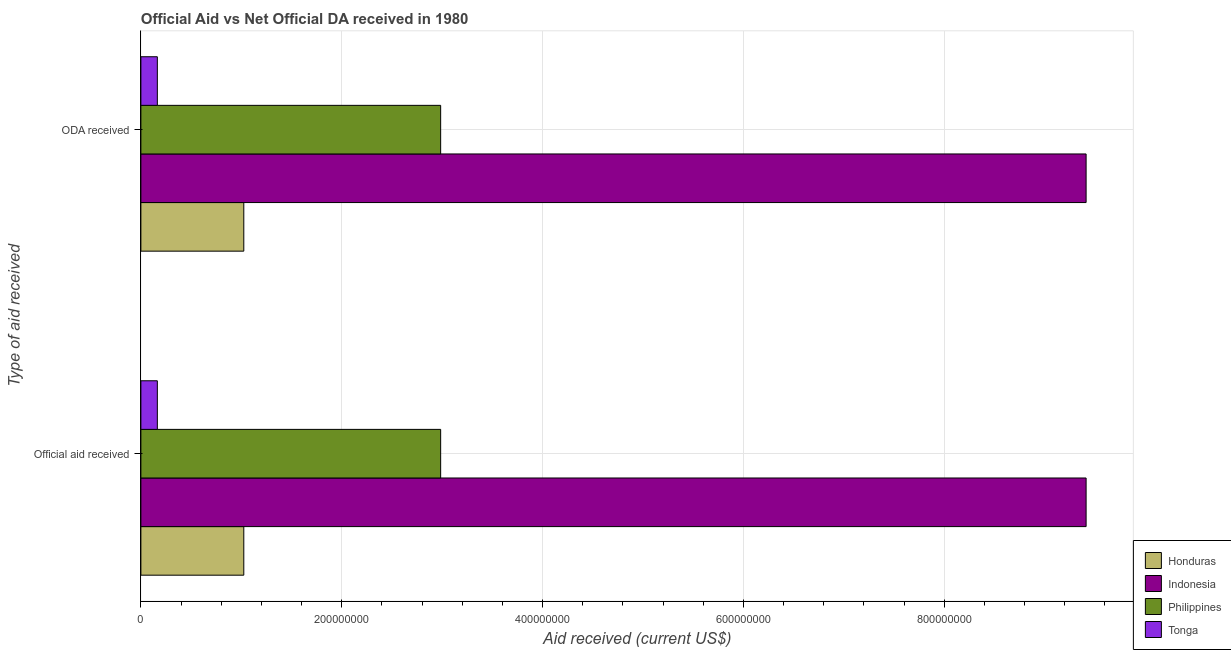How many groups of bars are there?
Keep it short and to the point. 2. How many bars are there on the 2nd tick from the top?
Keep it short and to the point. 4. How many bars are there on the 1st tick from the bottom?
Ensure brevity in your answer.  4. What is the label of the 2nd group of bars from the top?
Provide a succinct answer. Official aid received. What is the oda received in Tonga?
Offer a very short reply. 1.64e+07. Across all countries, what is the maximum official aid received?
Make the answer very short. 9.41e+08. Across all countries, what is the minimum oda received?
Your answer should be compact. 1.64e+07. In which country was the oda received maximum?
Provide a succinct answer. Indonesia. In which country was the oda received minimum?
Your answer should be compact. Tonga. What is the total official aid received in the graph?
Provide a short and direct response. 1.36e+09. What is the difference between the official aid received in Indonesia and that in Tonga?
Your answer should be compact. 9.25e+08. What is the difference between the official aid received in Philippines and the oda received in Honduras?
Your answer should be compact. 1.96e+08. What is the average oda received per country?
Give a very brief answer. 3.40e+08. What is the difference between the oda received and official aid received in Philippines?
Make the answer very short. 0. In how many countries, is the oda received greater than 200000000 US$?
Keep it short and to the point. 2. What is the ratio of the official aid received in Philippines to that in Indonesia?
Give a very brief answer. 0.32. What does the 4th bar from the top in ODA received represents?
Your answer should be very brief. Honduras. How many countries are there in the graph?
Give a very brief answer. 4. Does the graph contain any zero values?
Provide a succinct answer. No. How many legend labels are there?
Give a very brief answer. 4. How are the legend labels stacked?
Keep it short and to the point. Vertical. What is the title of the graph?
Give a very brief answer. Official Aid vs Net Official DA received in 1980 . Does "Malaysia" appear as one of the legend labels in the graph?
Your answer should be very brief. No. What is the label or title of the X-axis?
Ensure brevity in your answer.  Aid received (current US$). What is the label or title of the Y-axis?
Your answer should be compact. Type of aid received. What is the Aid received (current US$) in Honduras in Official aid received?
Offer a terse response. 1.02e+08. What is the Aid received (current US$) in Indonesia in Official aid received?
Give a very brief answer. 9.41e+08. What is the Aid received (current US$) of Philippines in Official aid received?
Make the answer very short. 2.99e+08. What is the Aid received (current US$) in Tonga in Official aid received?
Offer a very short reply. 1.64e+07. What is the Aid received (current US$) of Honduras in ODA received?
Offer a terse response. 1.02e+08. What is the Aid received (current US$) of Indonesia in ODA received?
Make the answer very short. 9.41e+08. What is the Aid received (current US$) of Philippines in ODA received?
Your response must be concise. 2.99e+08. What is the Aid received (current US$) of Tonga in ODA received?
Offer a terse response. 1.64e+07. Across all Type of aid received, what is the maximum Aid received (current US$) in Honduras?
Make the answer very short. 1.02e+08. Across all Type of aid received, what is the maximum Aid received (current US$) of Indonesia?
Make the answer very short. 9.41e+08. Across all Type of aid received, what is the maximum Aid received (current US$) of Philippines?
Make the answer very short. 2.99e+08. Across all Type of aid received, what is the maximum Aid received (current US$) in Tonga?
Make the answer very short. 1.64e+07. Across all Type of aid received, what is the minimum Aid received (current US$) in Honduras?
Ensure brevity in your answer.  1.02e+08. Across all Type of aid received, what is the minimum Aid received (current US$) of Indonesia?
Offer a very short reply. 9.41e+08. Across all Type of aid received, what is the minimum Aid received (current US$) in Philippines?
Offer a very short reply. 2.99e+08. Across all Type of aid received, what is the minimum Aid received (current US$) in Tonga?
Provide a short and direct response. 1.64e+07. What is the total Aid received (current US$) in Honduras in the graph?
Ensure brevity in your answer.  2.05e+08. What is the total Aid received (current US$) in Indonesia in the graph?
Make the answer very short. 1.88e+09. What is the total Aid received (current US$) of Philippines in the graph?
Your answer should be compact. 5.97e+08. What is the total Aid received (current US$) of Tonga in the graph?
Provide a succinct answer. 3.28e+07. What is the difference between the Aid received (current US$) in Philippines in Official aid received and that in ODA received?
Make the answer very short. 0. What is the difference between the Aid received (current US$) in Tonga in Official aid received and that in ODA received?
Provide a short and direct response. 0. What is the difference between the Aid received (current US$) of Honduras in Official aid received and the Aid received (current US$) of Indonesia in ODA received?
Your response must be concise. -8.39e+08. What is the difference between the Aid received (current US$) of Honduras in Official aid received and the Aid received (current US$) of Philippines in ODA received?
Keep it short and to the point. -1.96e+08. What is the difference between the Aid received (current US$) of Honduras in Official aid received and the Aid received (current US$) of Tonga in ODA received?
Provide a short and direct response. 8.61e+07. What is the difference between the Aid received (current US$) in Indonesia in Official aid received and the Aid received (current US$) in Philippines in ODA received?
Your answer should be very brief. 6.43e+08. What is the difference between the Aid received (current US$) in Indonesia in Official aid received and the Aid received (current US$) in Tonga in ODA received?
Your response must be concise. 9.25e+08. What is the difference between the Aid received (current US$) in Philippines in Official aid received and the Aid received (current US$) in Tonga in ODA received?
Provide a short and direct response. 2.82e+08. What is the average Aid received (current US$) of Honduras per Type of aid received?
Offer a terse response. 1.02e+08. What is the average Aid received (current US$) of Indonesia per Type of aid received?
Make the answer very short. 9.41e+08. What is the average Aid received (current US$) of Philippines per Type of aid received?
Your response must be concise. 2.99e+08. What is the average Aid received (current US$) of Tonga per Type of aid received?
Give a very brief answer. 1.64e+07. What is the difference between the Aid received (current US$) of Honduras and Aid received (current US$) of Indonesia in Official aid received?
Make the answer very short. -8.39e+08. What is the difference between the Aid received (current US$) of Honduras and Aid received (current US$) of Philippines in Official aid received?
Give a very brief answer. -1.96e+08. What is the difference between the Aid received (current US$) in Honduras and Aid received (current US$) in Tonga in Official aid received?
Your answer should be very brief. 8.61e+07. What is the difference between the Aid received (current US$) of Indonesia and Aid received (current US$) of Philippines in Official aid received?
Keep it short and to the point. 6.43e+08. What is the difference between the Aid received (current US$) of Indonesia and Aid received (current US$) of Tonga in Official aid received?
Your answer should be very brief. 9.25e+08. What is the difference between the Aid received (current US$) in Philippines and Aid received (current US$) in Tonga in Official aid received?
Provide a short and direct response. 2.82e+08. What is the difference between the Aid received (current US$) of Honduras and Aid received (current US$) of Indonesia in ODA received?
Your answer should be very brief. -8.39e+08. What is the difference between the Aid received (current US$) in Honduras and Aid received (current US$) in Philippines in ODA received?
Provide a short and direct response. -1.96e+08. What is the difference between the Aid received (current US$) of Honduras and Aid received (current US$) of Tonga in ODA received?
Your response must be concise. 8.61e+07. What is the difference between the Aid received (current US$) in Indonesia and Aid received (current US$) in Philippines in ODA received?
Offer a terse response. 6.43e+08. What is the difference between the Aid received (current US$) of Indonesia and Aid received (current US$) of Tonga in ODA received?
Give a very brief answer. 9.25e+08. What is the difference between the Aid received (current US$) of Philippines and Aid received (current US$) of Tonga in ODA received?
Give a very brief answer. 2.82e+08. What is the ratio of the Aid received (current US$) in Honduras in Official aid received to that in ODA received?
Provide a succinct answer. 1. What is the ratio of the Aid received (current US$) in Indonesia in Official aid received to that in ODA received?
Your answer should be compact. 1. What is the difference between the highest and the second highest Aid received (current US$) in Honduras?
Give a very brief answer. 0. What is the difference between the highest and the second highest Aid received (current US$) in Indonesia?
Keep it short and to the point. 0. What is the difference between the highest and the second highest Aid received (current US$) in Philippines?
Ensure brevity in your answer.  0. What is the difference between the highest and the lowest Aid received (current US$) of Indonesia?
Keep it short and to the point. 0. What is the difference between the highest and the lowest Aid received (current US$) in Philippines?
Provide a succinct answer. 0. 